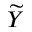<formula> <loc_0><loc_0><loc_500><loc_500>\widetilde { Y }</formula> 